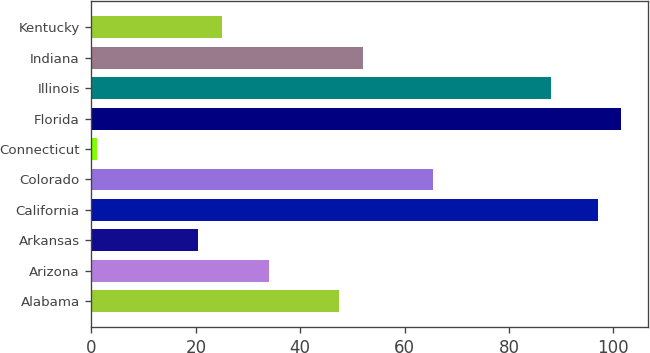Convert chart to OTSL. <chart><loc_0><loc_0><loc_500><loc_500><bar_chart><fcel>Alabama<fcel>Arizona<fcel>Arkansas<fcel>California<fcel>Colorado<fcel>Connecticut<fcel>Florida<fcel>Illinois<fcel>Indiana<fcel>Kentucky<nl><fcel>47.5<fcel>34<fcel>20.5<fcel>97<fcel>65.5<fcel>1<fcel>101.5<fcel>88<fcel>52<fcel>25<nl></chart> 